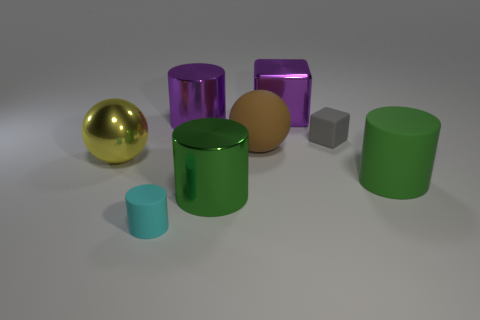What is the size of the yellow object that is the same shape as the large brown rubber object?
Keep it short and to the point. Large. Is the color of the metal ball the same as the rubber cube?
Your response must be concise. No. Is there any other thing that has the same shape as the gray thing?
Give a very brief answer. Yes. Is there a large yellow object on the right side of the small rubber thing on the left side of the brown rubber object?
Provide a succinct answer. No. What is the color of the other large object that is the same shape as the big yellow thing?
Your answer should be very brief. Brown. How many shiny blocks are the same color as the rubber block?
Give a very brief answer. 0. There is a shiny object that is in front of the sphere on the left side of the matte cylinder left of the gray rubber object; what color is it?
Provide a succinct answer. Green. Do the gray thing and the small cylinder have the same material?
Provide a succinct answer. Yes. Does the green shiny object have the same shape as the gray matte object?
Offer a very short reply. No. Are there the same number of balls to the right of the tiny gray matte block and shiny cubes that are behind the big shiny cube?
Provide a short and direct response. Yes. 